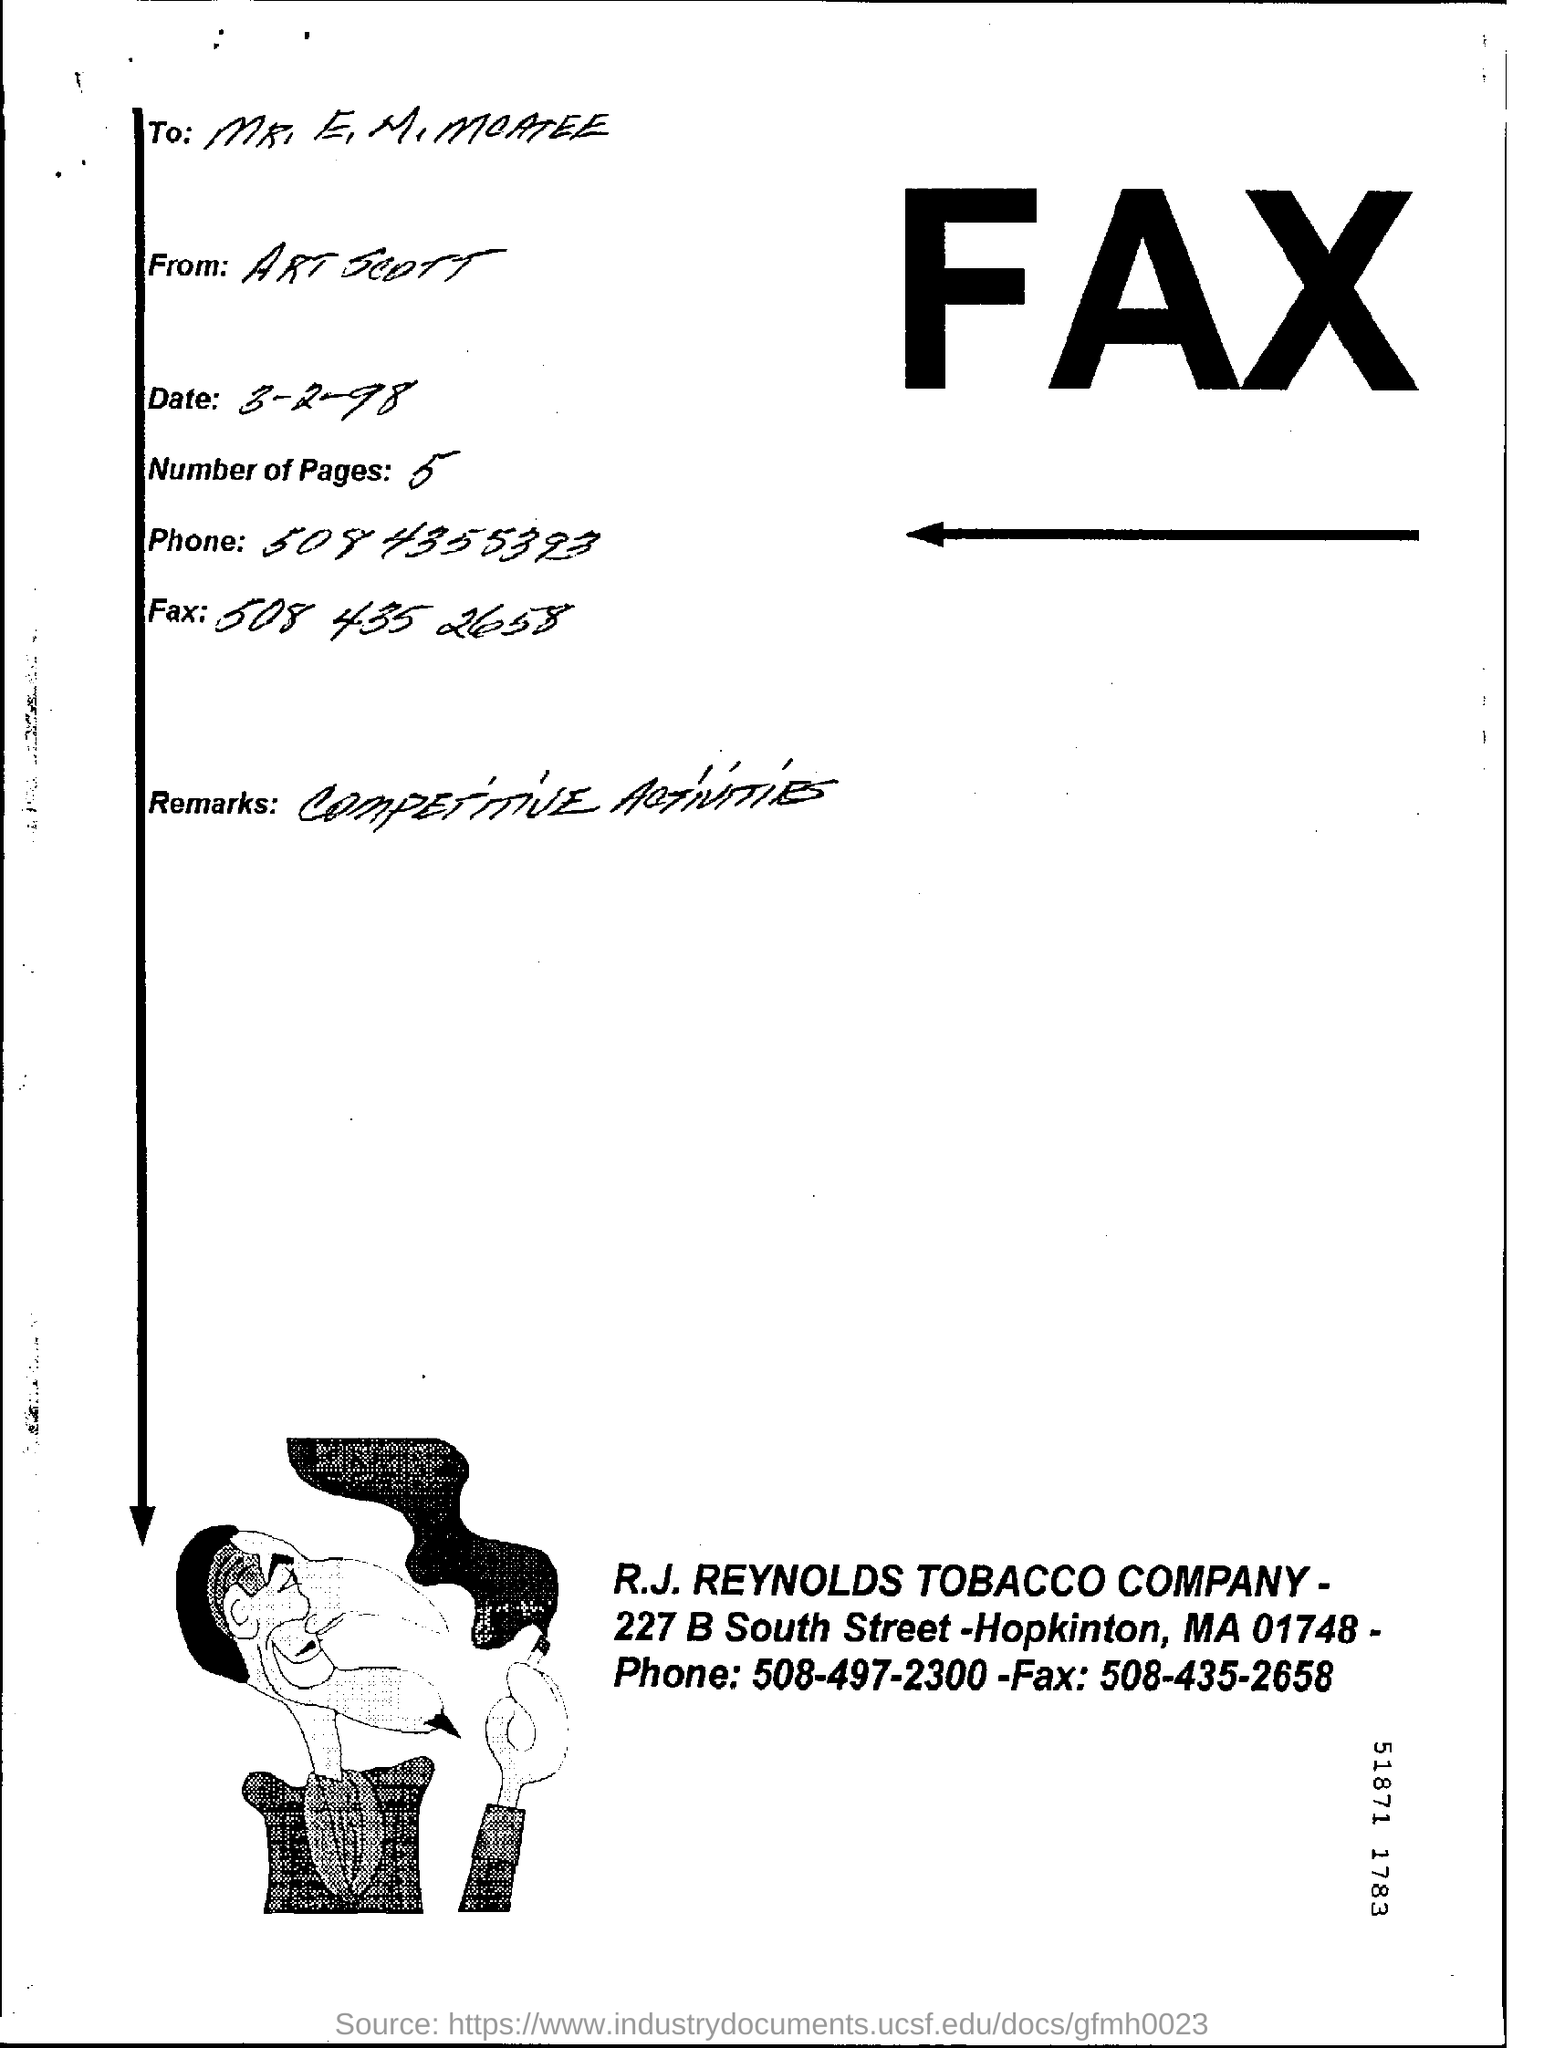When is the fax dated?
Give a very brief answer. 3-2-98. How many pages are there?
Offer a terse response. 5. Which company's name is mentioned?
Keep it short and to the point. R.J. REYNOLDS TOBACCO COMPANY. 